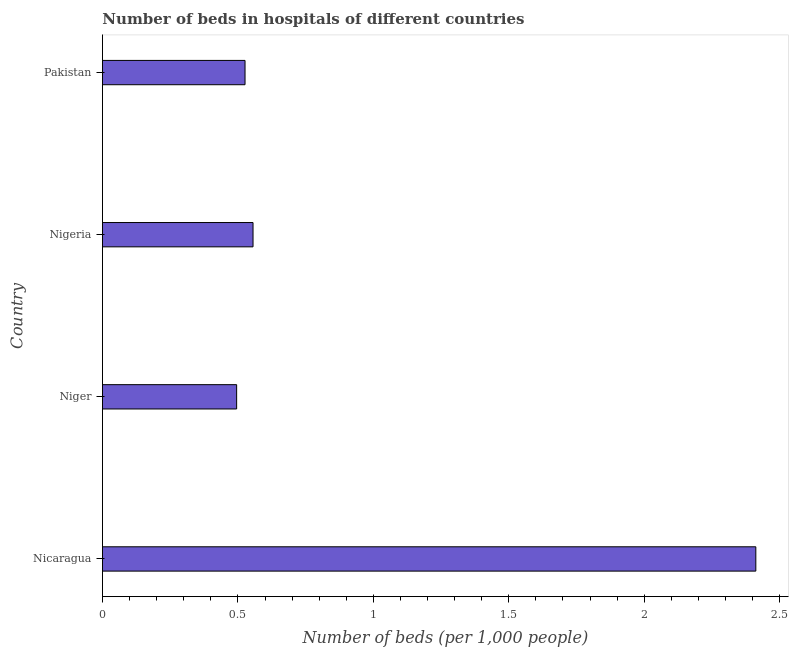Does the graph contain grids?
Offer a terse response. No. What is the title of the graph?
Give a very brief answer. Number of beds in hospitals of different countries. What is the label or title of the X-axis?
Provide a short and direct response. Number of beds (per 1,0 people). What is the number of hospital beds in Niger?
Keep it short and to the point. 0.5. Across all countries, what is the maximum number of hospital beds?
Keep it short and to the point. 2.41. Across all countries, what is the minimum number of hospital beds?
Offer a very short reply. 0.5. In which country was the number of hospital beds maximum?
Offer a terse response. Nicaragua. In which country was the number of hospital beds minimum?
Keep it short and to the point. Niger. What is the sum of the number of hospital beds?
Your answer should be compact. 3.99. What is the difference between the number of hospital beds in Niger and Pakistan?
Keep it short and to the point. -0.03. What is the median number of hospital beds?
Offer a very short reply. 0.54. In how many countries, is the number of hospital beds greater than 2 %?
Your answer should be very brief. 1. What is the ratio of the number of hospital beds in Nigeria to that in Pakistan?
Your answer should be very brief. 1.06. Is the number of hospital beds in Nicaragua less than that in Nigeria?
Your response must be concise. No. Is the difference between the number of hospital beds in Nicaragua and Nigeria greater than the difference between any two countries?
Your response must be concise. No. What is the difference between the highest and the second highest number of hospital beds?
Ensure brevity in your answer.  1.86. What is the difference between the highest and the lowest number of hospital beds?
Offer a very short reply. 1.92. In how many countries, is the number of hospital beds greater than the average number of hospital beds taken over all countries?
Give a very brief answer. 1. Are all the bars in the graph horizontal?
Give a very brief answer. Yes. What is the difference between two consecutive major ticks on the X-axis?
Your answer should be compact. 0.5. Are the values on the major ticks of X-axis written in scientific E-notation?
Your answer should be very brief. No. What is the Number of beds (per 1,000 people) of Nicaragua?
Your answer should be compact. 2.41. What is the Number of beds (per 1,000 people) in Niger?
Offer a very short reply. 0.5. What is the Number of beds (per 1,000 people) of Nigeria?
Offer a very short reply. 0.56. What is the Number of beds (per 1,000 people) of Pakistan?
Provide a short and direct response. 0.53. What is the difference between the Number of beds (per 1,000 people) in Nicaragua and Niger?
Offer a terse response. 1.92. What is the difference between the Number of beds (per 1,000 people) in Nicaragua and Nigeria?
Offer a terse response. 1.86. What is the difference between the Number of beds (per 1,000 people) in Nicaragua and Pakistan?
Make the answer very short. 1.89. What is the difference between the Number of beds (per 1,000 people) in Niger and Nigeria?
Provide a short and direct response. -0.06. What is the difference between the Number of beds (per 1,000 people) in Niger and Pakistan?
Offer a very short reply. -0.03. What is the difference between the Number of beds (per 1,000 people) in Nigeria and Pakistan?
Give a very brief answer. 0.03. What is the ratio of the Number of beds (per 1,000 people) in Nicaragua to that in Niger?
Offer a terse response. 4.87. What is the ratio of the Number of beds (per 1,000 people) in Nicaragua to that in Nigeria?
Your answer should be very brief. 4.34. What is the ratio of the Number of beds (per 1,000 people) in Nicaragua to that in Pakistan?
Keep it short and to the point. 4.58. What is the ratio of the Number of beds (per 1,000 people) in Niger to that in Nigeria?
Offer a terse response. 0.89. What is the ratio of the Number of beds (per 1,000 people) in Niger to that in Pakistan?
Make the answer very short. 0.94. What is the ratio of the Number of beds (per 1,000 people) in Nigeria to that in Pakistan?
Keep it short and to the point. 1.06. 